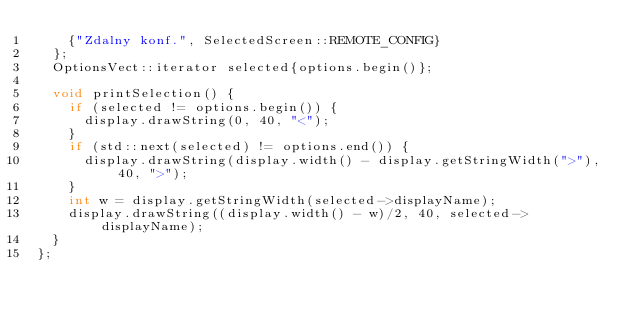Convert code to text. <code><loc_0><loc_0><loc_500><loc_500><_C_>    {"Zdalny konf.", SelectedScreen::REMOTE_CONFIG}
  };
  OptionsVect::iterator selected{options.begin()};

  void printSelection() {
    if (selected != options.begin()) {
      display.drawString(0, 40, "<");
    }
    if (std::next(selected) != options.end()) {
      display.drawString(display.width() - display.getStringWidth(">"), 40, ">");
    }
    int w = display.getStringWidth(selected->displayName);
    display.drawString((display.width() - w)/2, 40, selected->displayName);
  }
};

</code> 